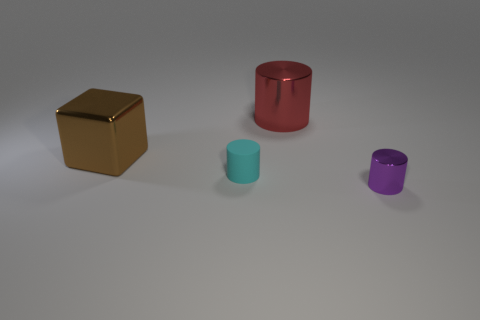Add 1 big brown blocks. How many objects exist? 5 Subtract all blocks. How many objects are left? 3 Add 1 cyan matte objects. How many cyan matte objects exist? 2 Subtract 0 red cubes. How many objects are left? 4 Subtract all matte objects. Subtract all small cylinders. How many objects are left? 1 Add 4 cylinders. How many cylinders are left? 7 